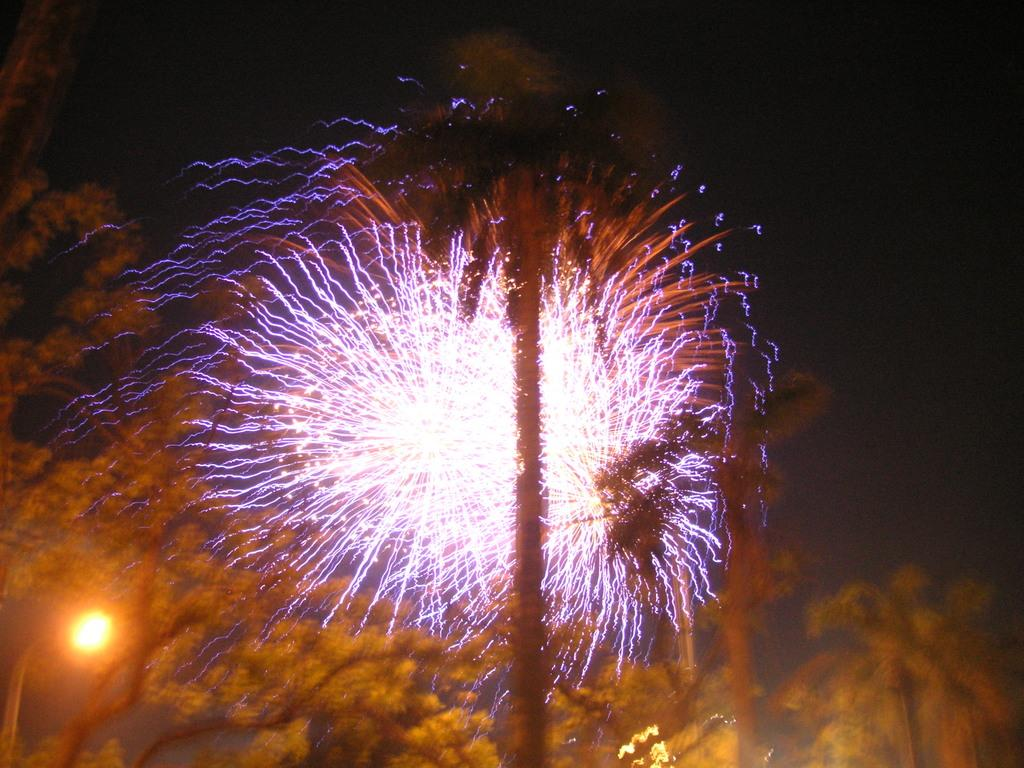What type of illumination is present in the image? There are colorful lights in the image. What can be seen in the background of the image? The background of the image includes the sun. What colors are the sun depicted in? The sun is in yellow and orange colors. How many sticks are being used by the brother in the image? There is no brother or sticks present in the image. What type of discovery is being made in the image? There is no discovery being made in the image; it primarily features colorful lights and the sun. 